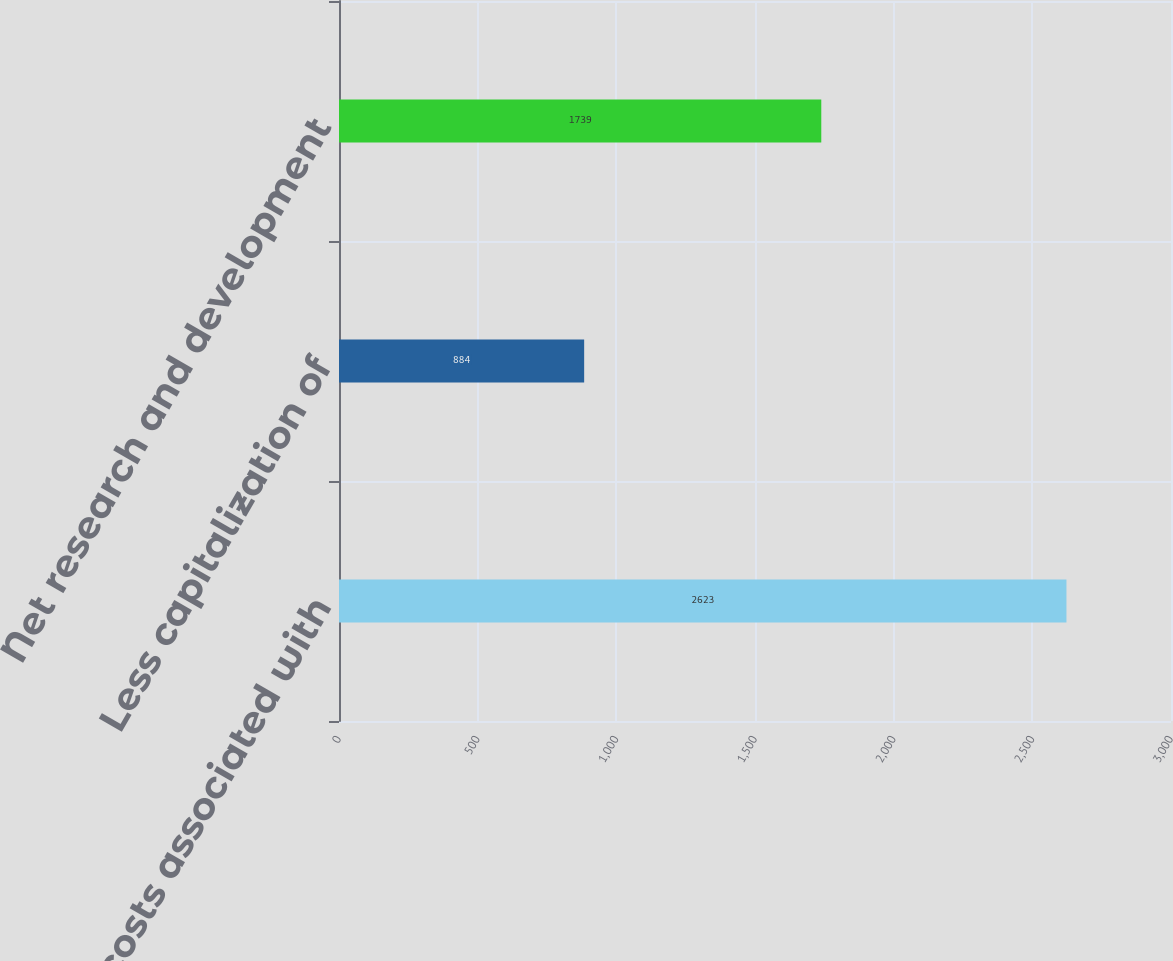Convert chart to OTSL. <chart><loc_0><loc_0><loc_500><loc_500><bar_chart><fcel>Total costs associated with<fcel>Less capitalization of<fcel>Net research and development<nl><fcel>2623<fcel>884<fcel>1739<nl></chart> 